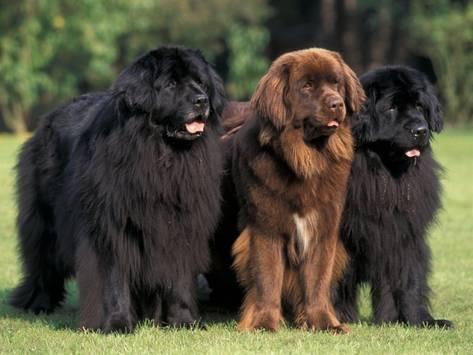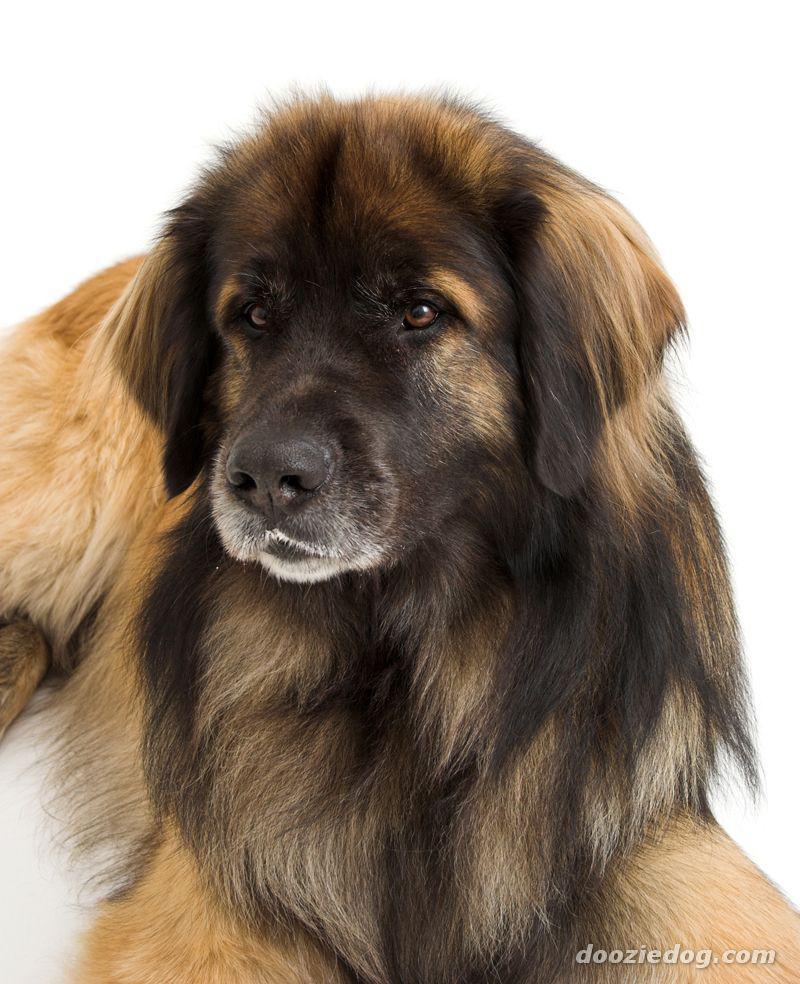The first image is the image on the left, the second image is the image on the right. Considering the images on both sides, is "There is more than one dog in one of the images." valid? Answer yes or no. Yes. 